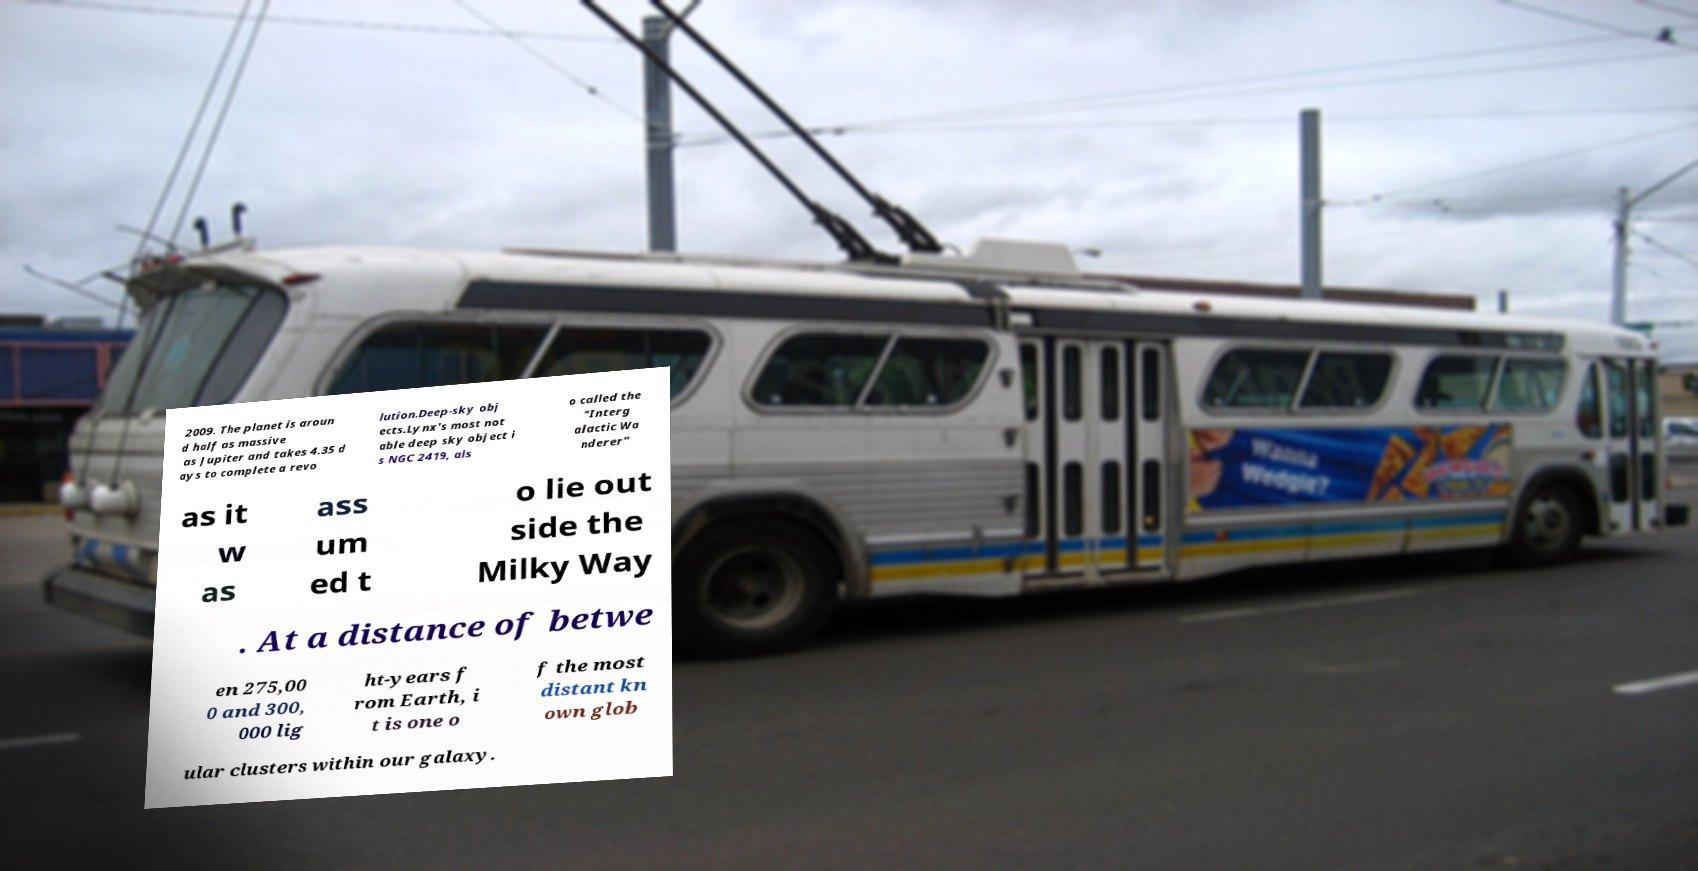What messages or text are displayed in this image? I need them in a readable, typed format. 2009. The planet is aroun d half as massive as Jupiter and takes 4.35 d ays to complete a revo lution.Deep-sky obj ects.Lynx's most not able deep sky object i s NGC 2419, als o called the "Interg alactic Wa nderer" as it w as ass um ed t o lie out side the Milky Way . At a distance of betwe en 275,00 0 and 300, 000 lig ht-years f rom Earth, i t is one o f the most distant kn own glob ular clusters within our galaxy. 